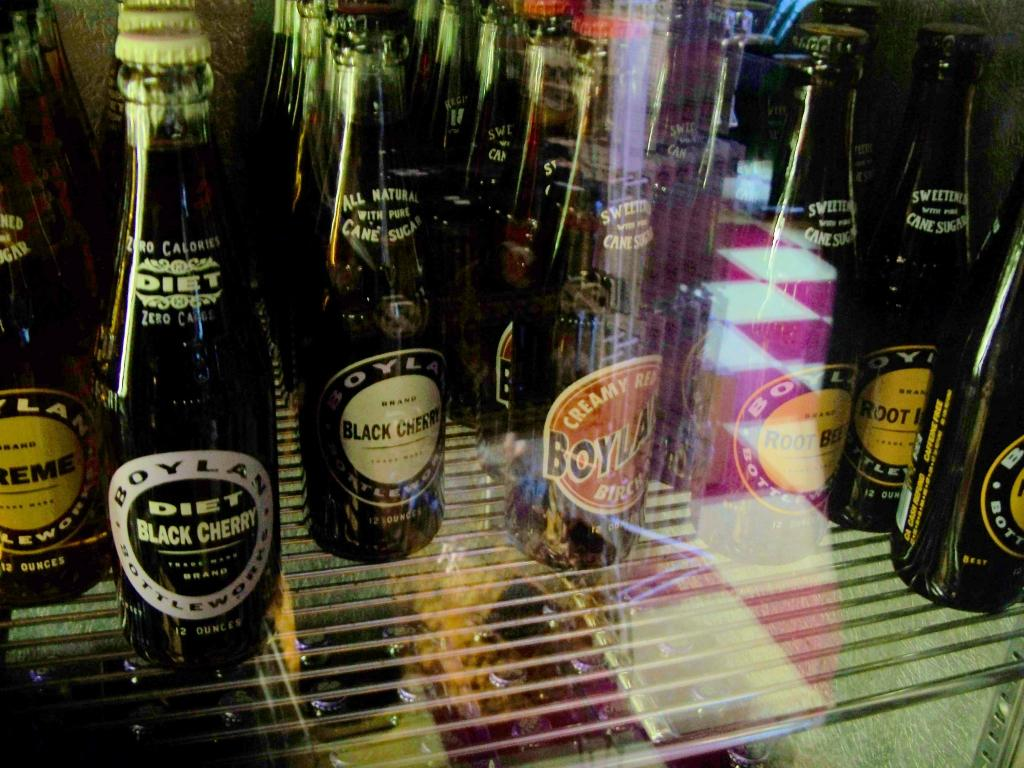Provide a one-sentence caption for the provided image. Bottles of Diet Black Cherry alcohol sitting on a store shelf. 